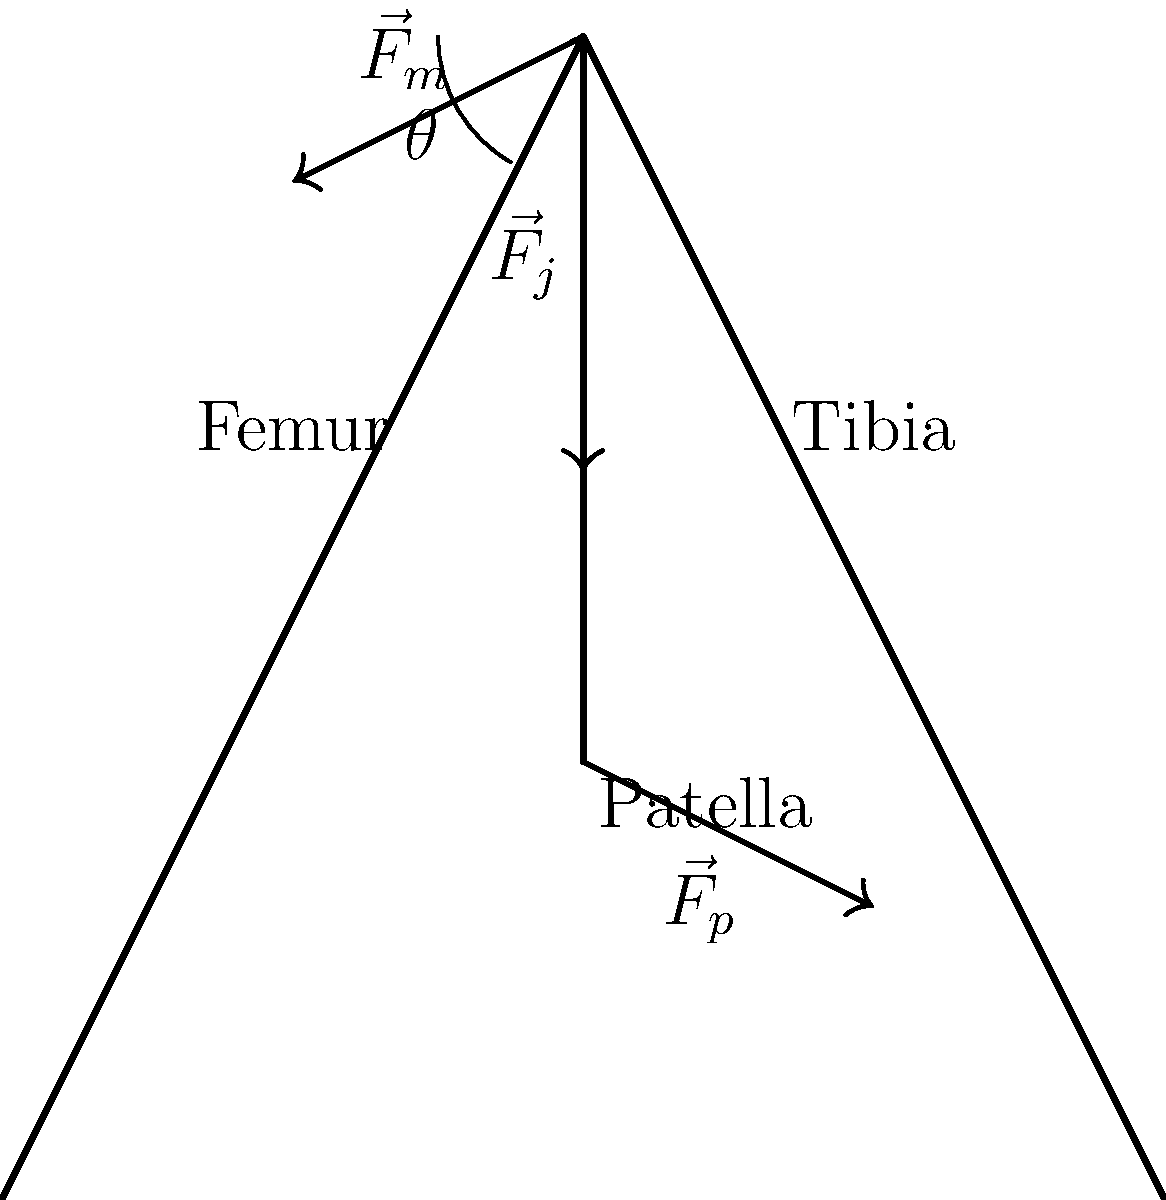Given the simplified skeletal diagram of a human knee joint during walking, analyze the force distribution and determine the relationship between the joint reaction force ($\vec{F}_j$), the muscle force ($\vec{F}_m$), and the patellar tendon force ($\vec{F}_p$). Assuming the system is in static equilibrium, express $\vec{F}_j$ in terms of $\vec{F}_m$ and $\vec{F}_p$. To analyze the force distribution and determine the relationship between the forces, we'll follow these steps:

1. Identify the forces acting on the joint:
   - $\vec{F}_j$: Joint reaction force (vertical)
   - $\vec{F}_m$: Muscle force (acting at an angle $\theta$ from the vertical)
   - $\vec{F}_p$: Patellar tendon force (acting at an angle from the vertical)

2. Apply the principle of static equilibrium:
   For a system in static equilibrium, the sum of all forces must be zero.
   $$\sum \vec{F} = 0$$

3. Resolve forces into vertical and horizontal components:
   Vertical: $$F_j + F_m \cos\theta - F_p \cos\phi = 0$$
   Horizontal: $$F_m \sin\theta - F_p \sin\phi = 0$$
   Where $\phi$ is the angle between $\vec{F}_p$ and the vertical.

4. From the horizontal equation:
   $$F_p \sin\phi = F_m \sin\theta$$

5. Substitute this into the vertical equation:
   $$F_j + F_m \cos\theta - F_m \sin\theta \cot\phi = 0$$

6. Rearrange to express $F_j$ in terms of $F_m$:
   $$F_j = F_m (\sin\theta \cot\phi - \cos\theta)$$

7. The final relationship can be written as:
   $$\vec{F}_j = \vec{F}_m (\sin\theta \cot\phi - \cos\theta) - \vec{F}_p$$

This equation expresses the joint reaction force in terms of the muscle force and patellar tendon force, taking into account the angles at which these forces act.
Answer: $\vec{F}_j = \vec{F}_m (\sin\theta \cot\phi - \cos\theta) - \vec{F}_p$ 